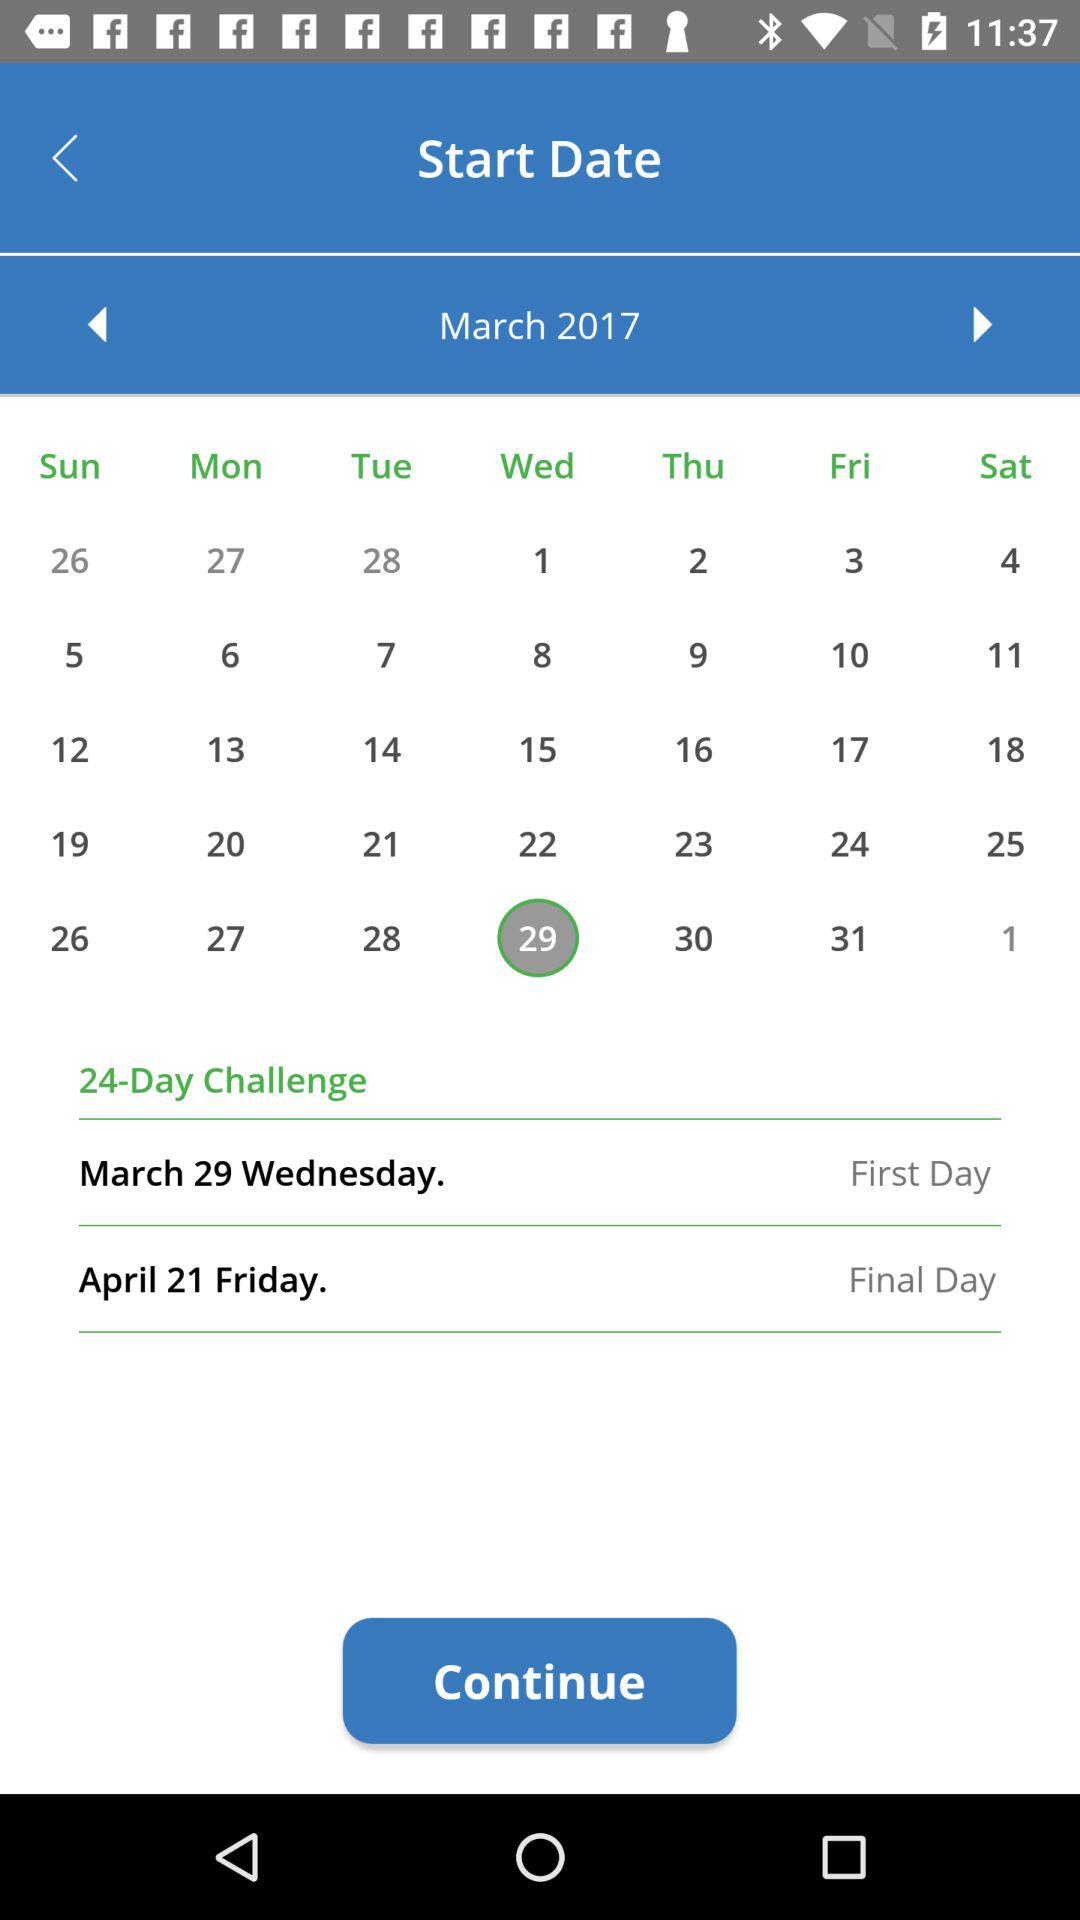What is the final day? The final day is Friday, April 21st. 